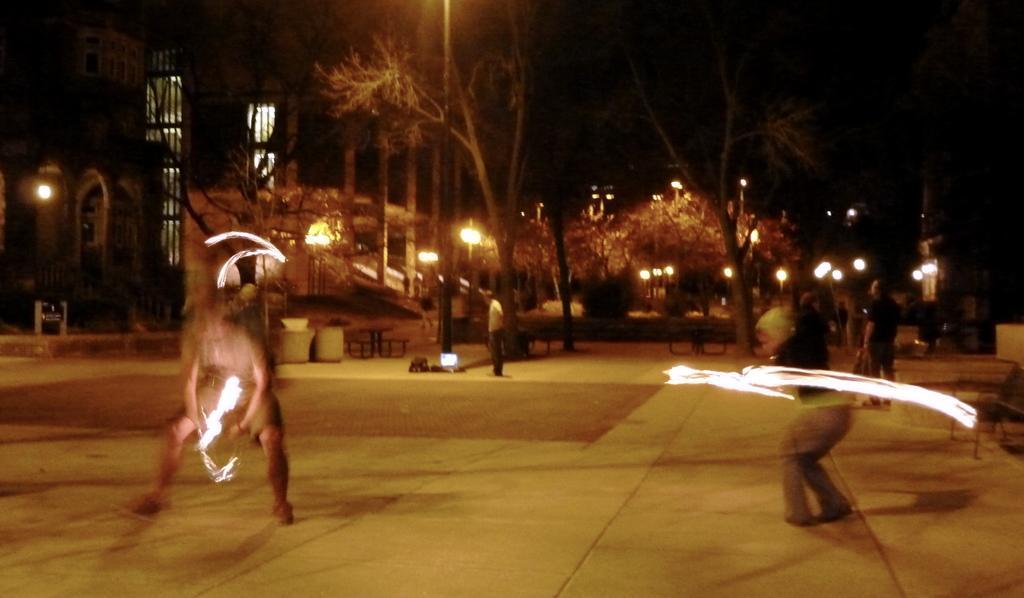Could you give a brief overview of what you see in this image? In this image there is one person standing at left side of this image and one person is in middle of this image and there are some persons standing on the right side of this image. There is a floor on the bottom of this image and there are some trees in the background, and there are some lights arranged as we can see in middle of this image. There is a building on the top left side of this image. 